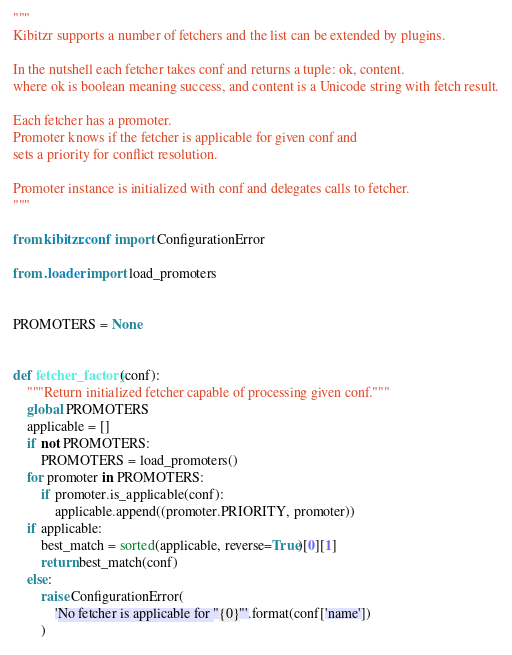<code> <loc_0><loc_0><loc_500><loc_500><_Python_>"""
Kibitzr supports a number of fetchers and the list can be extended by plugins.

In the nutshell each fetcher takes conf and returns a tuple: ok, content.
where ok is boolean meaning success, and content is a Unicode string with fetch result.

Each fetcher has a promoter.
Promoter knows if the fetcher is applicable for given conf and
sets a priority for conflict resolution.

Promoter instance is initialized with conf and delegates calls to fetcher.
"""

from kibitzr.conf import ConfigurationError

from .loader import load_promoters


PROMOTERS = None


def fetcher_factory(conf):
    """Return initialized fetcher capable of processing given conf."""
    global PROMOTERS
    applicable = []
    if not PROMOTERS:
        PROMOTERS = load_promoters()
    for promoter in PROMOTERS:
        if promoter.is_applicable(conf):
            applicable.append((promoter.PRIORITY, promoter))
    if applicable:
        best_match = sorted(applicable, reverse=True)[0][1]
        return best_match(conf)
    else:
        raise ConfigurationError(
            'No fetcher is applicable for "{0}"'.format(conf['name'])
        )
</code> 